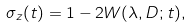<formula> <loc_0><loc_0><loc_500><loc_500>\sigma _ { z } ( t ) = 1 - 2 W ( \lambda , D ; t ) ,</formula> 